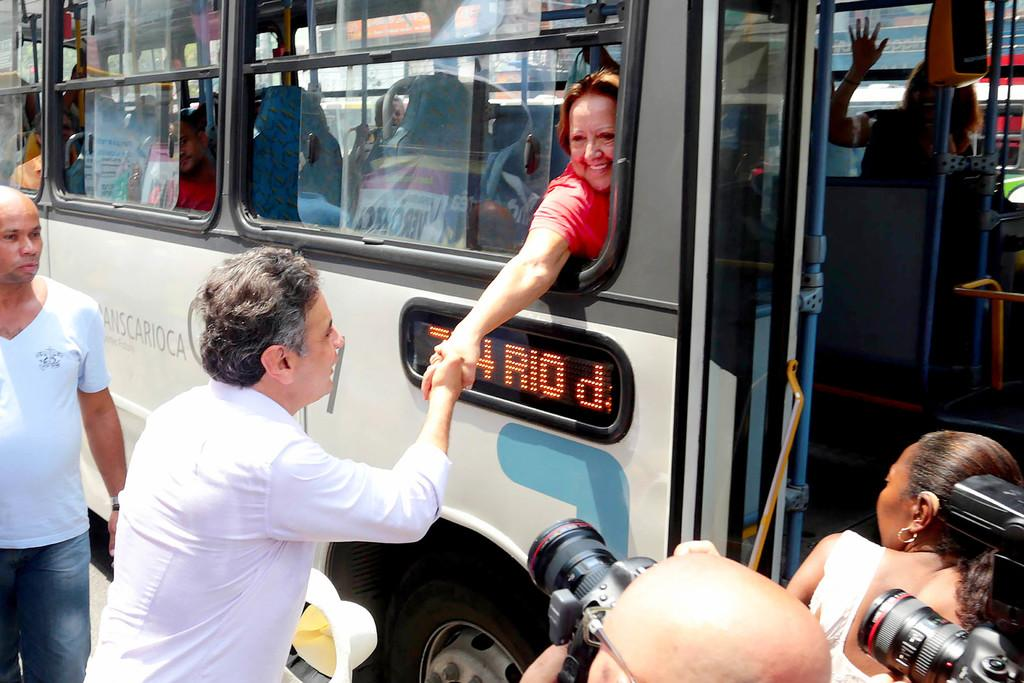What is happening between the woman and the man in the image? A woman is giving a handshake to a man from a bus window. Are there any other people in the image besides the woman and the man? Yes, there is another man standing beside the bus. What might the people taking pictures be doing? The people taking pictures might be capturing the scene or documenting the event. What type of structure is visible in the background of the image? There is no structure visible in the background of the image. Can you describe the mailbox located near the bus? There is no mailbox present in the image. 